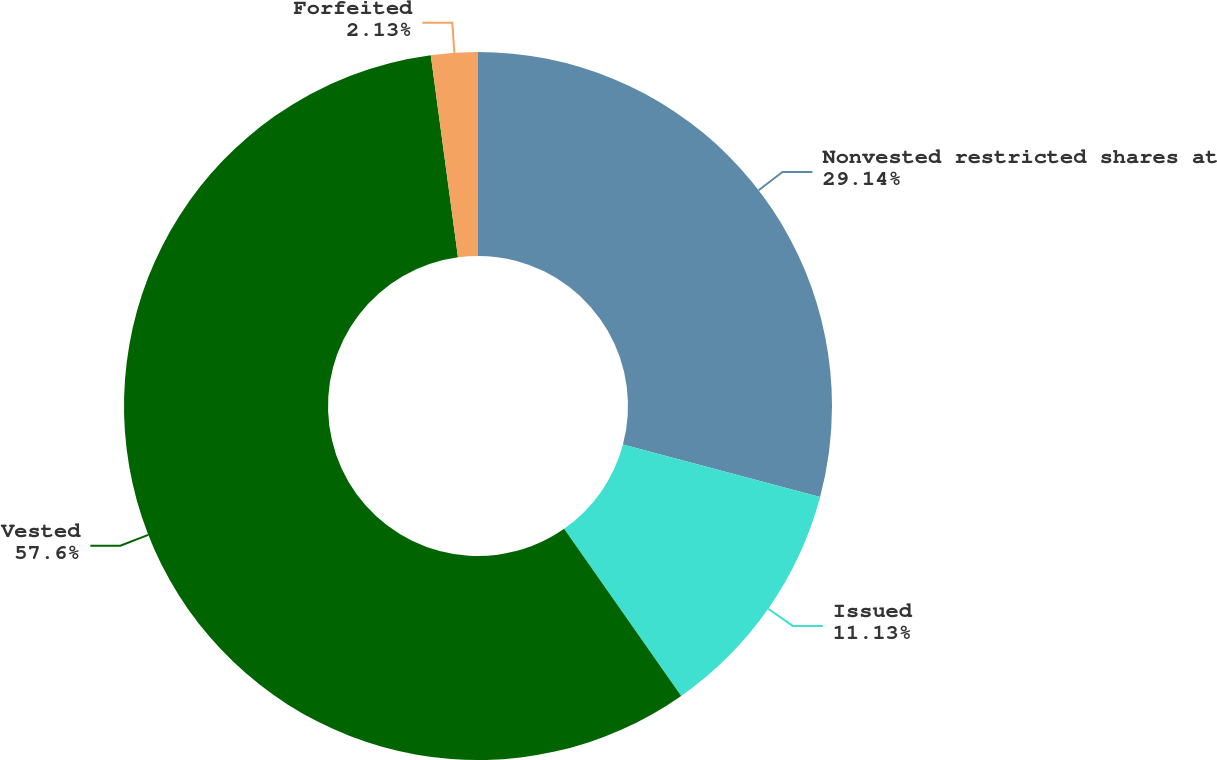<chart> <loc_0><loc_0><loc_500><loc_500><pie_chart><fcel>Nonvested restricted shares at<fcel>Issued<fcel>Vested<fcel>Forfeited<nl><fcel>29.14%<fcel>11.13%<fcel>57.6%<fcel>2.13%<nl></chart> 